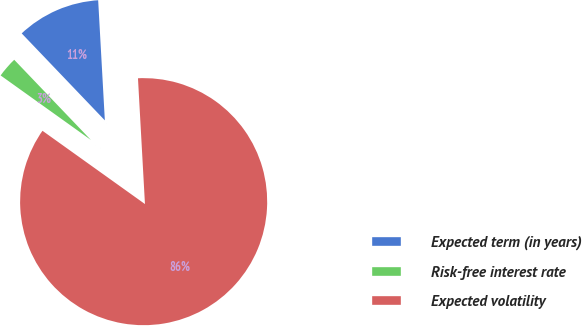<chart> <loc_0><loc_0><loc_500><loc_500><pie_chart><fcel>Expected term (in years)<fcel>Risk-free interest rate<fcel>Expected volatility<nl><fcel>11.26%<fcel>2.98%<fcel>85.77%<nl></chart> 